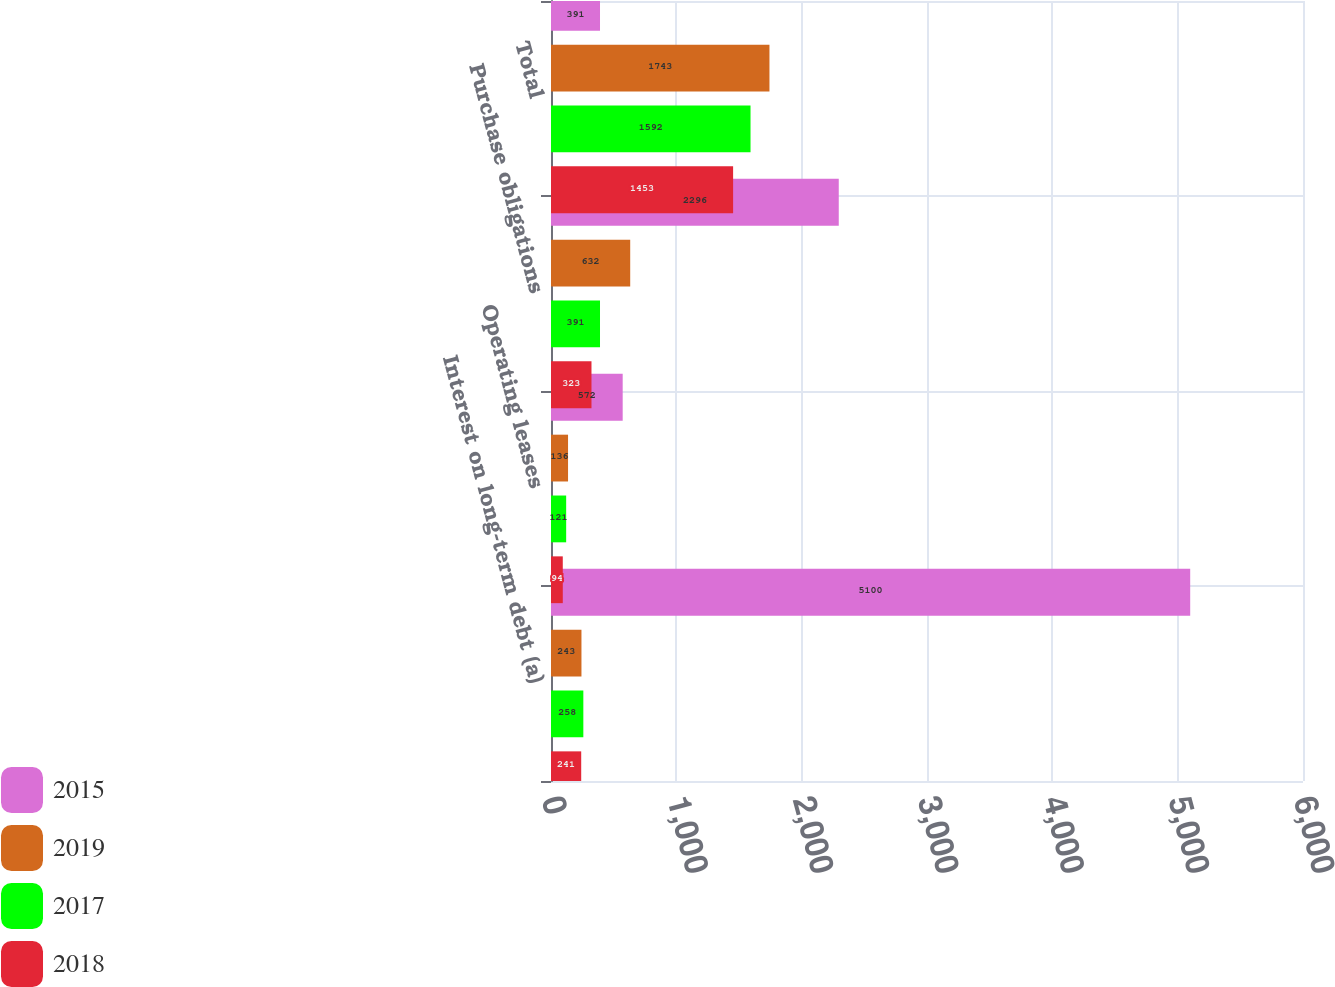<chart> <loc_0><loc_0><loc_500><loc_500><stacked_bar_chart><ecel><fcel>Interest on long-term debt (a)<fcel>Operating leases<fcel>Purchase obligations<fcel>Total<nl><fcel>2015<fcel>5100<fcel>572<fcel>2296<fcel>391<nl><fcel>2019<fcel>243<fcel>136<fcel>632<fcel>1743<nl><fcel>2017<fcel>258<fcel>121<fcel>391<fcel>1592<nl><fcel>2018<fcel>241<fcel>94<fcel>323<fcel>1453<nl></chart> 